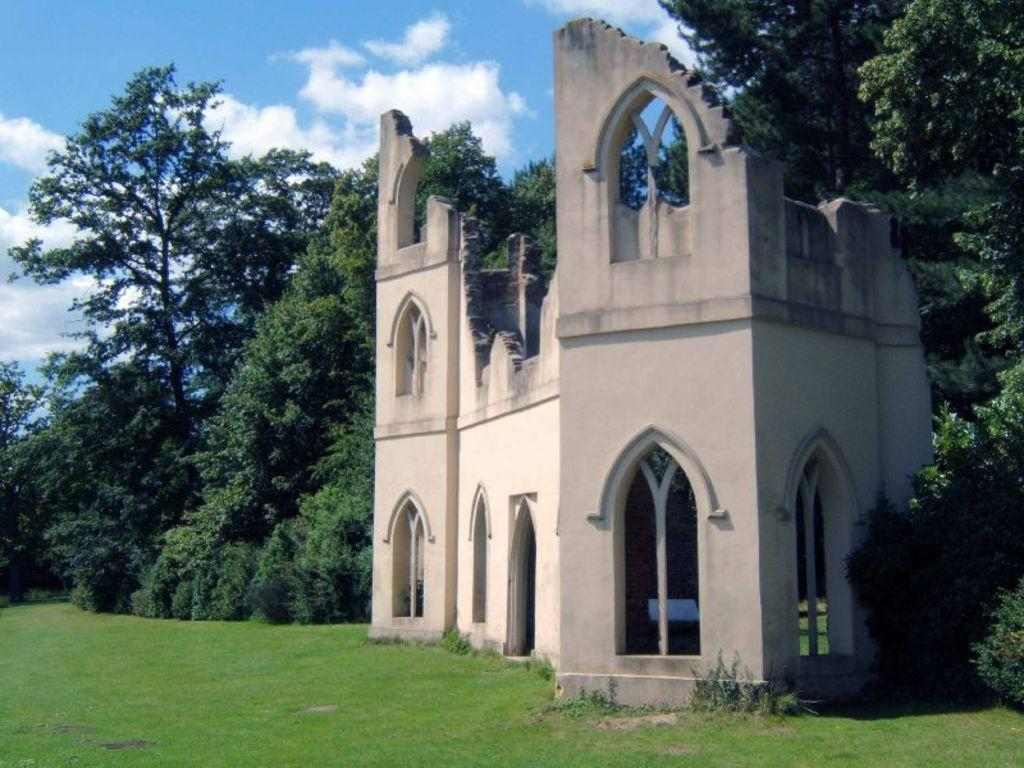What can be seen at the bottom of the image? The ground is visible in the image. What type of structure is present in the image? There is a building in the image, and it is cream in color. What type of vegetation is present in the image? There are trees in the image, and they are green in color. What is visible in the background of the image? The sky is visible in the background of the image. Can you see any rabbits using scissors in the image? There are no rabbits or scissors present in the image. 